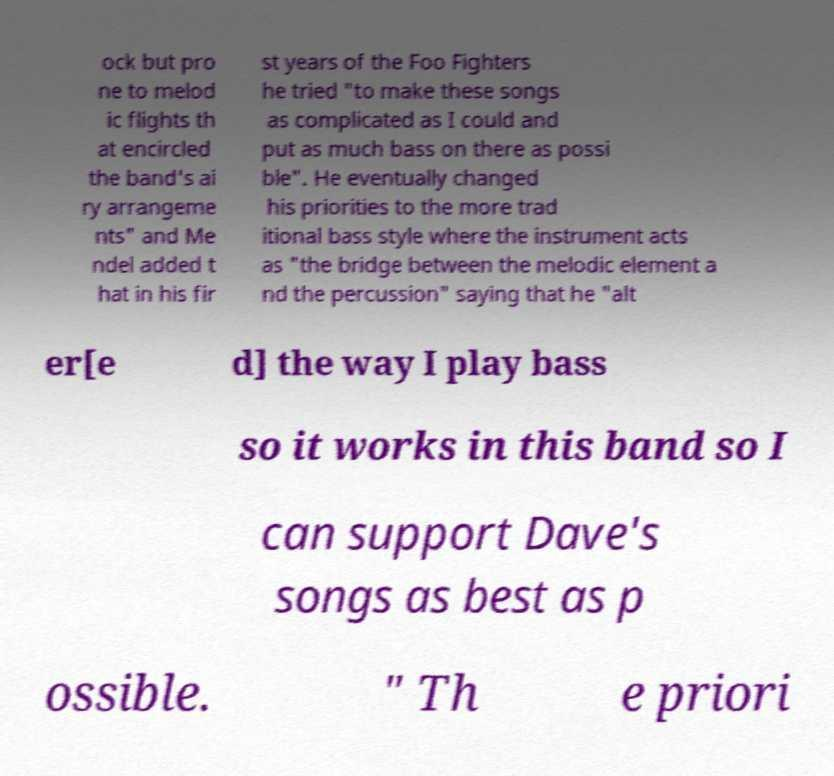Please read and relay the text visible in this image. What does it say? ock but pro ne to melod ic flights th at encircled the band's ai ry arrangeme nts" and Me ndel added t hat in his fir st years of the Foo Fighters he tried "to make these songs as complicated as I could and put as much bass on there as possi ble". He eventually changed his priorities to the more trad itional bass style where the instrument acts as "the bridge between the melodic element a nd the percussion" saying that he "alt er[e d] the way I play bass so it works in this band so I can support Dave's songs as best as p ossible. " Th e priori 